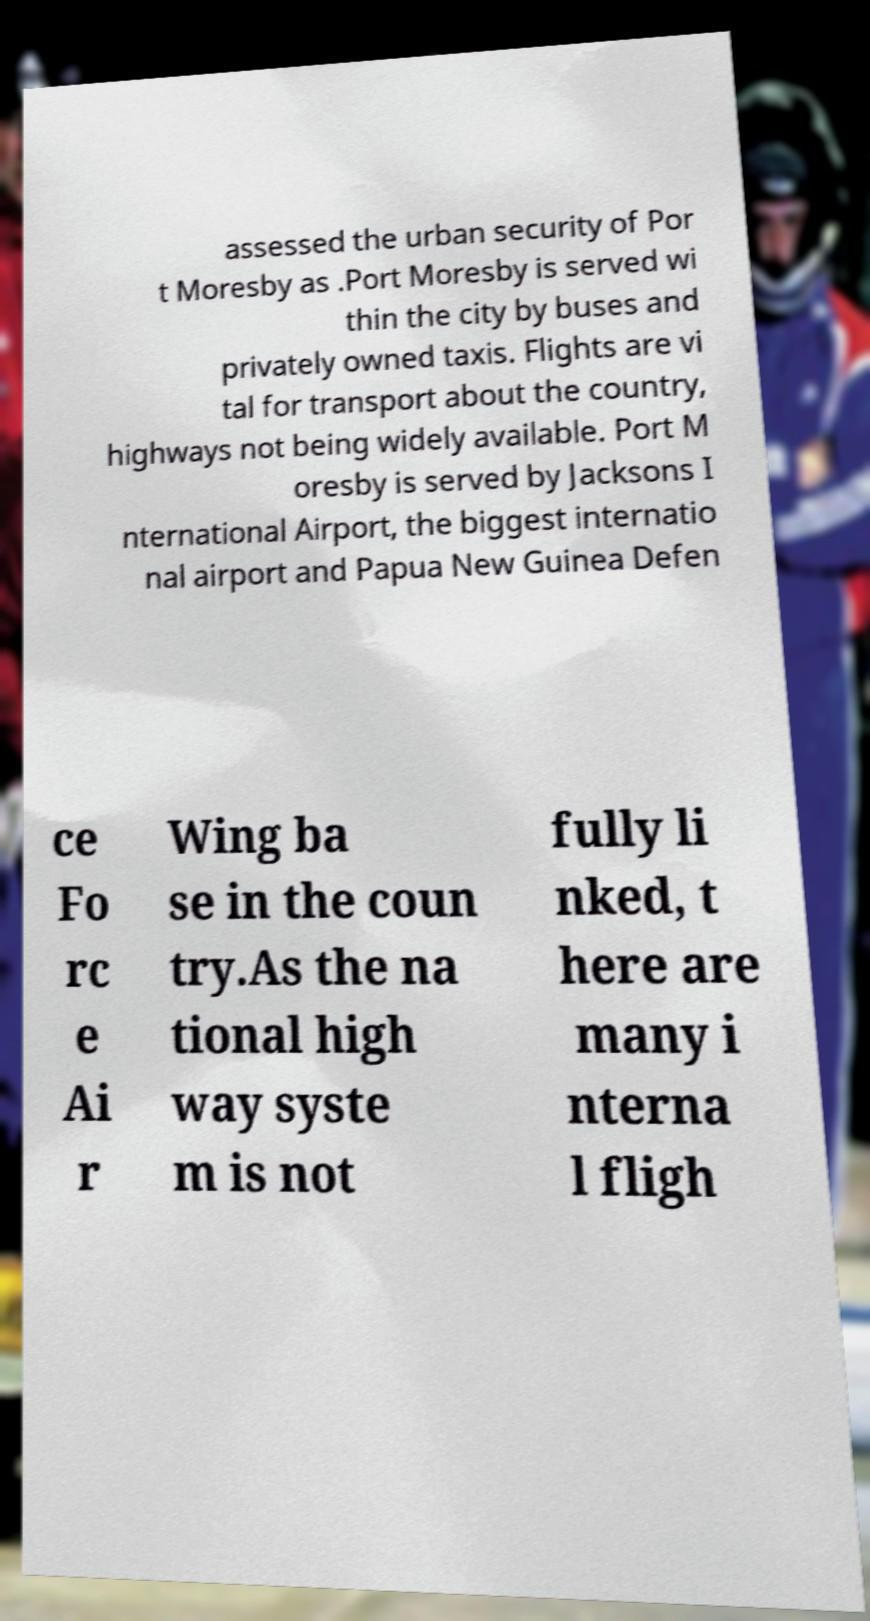Please identify and transcribe the text found in this image. assessed the urban security of Por t Moresby as .Port Moresby is served wi thin the city by buses and privately owned taxis. Flights are vi tal for transport about the country, highways not being widely available. Port M oresby is served by Jacksons I nternational Airport, the biggest internatio nal airport and Papua New Guinea Defen ce Fo rc e Ai r Wing ba se in the coun try.As the na tional high way syste m is not fully li nked, t here are many i nterna l fligh 